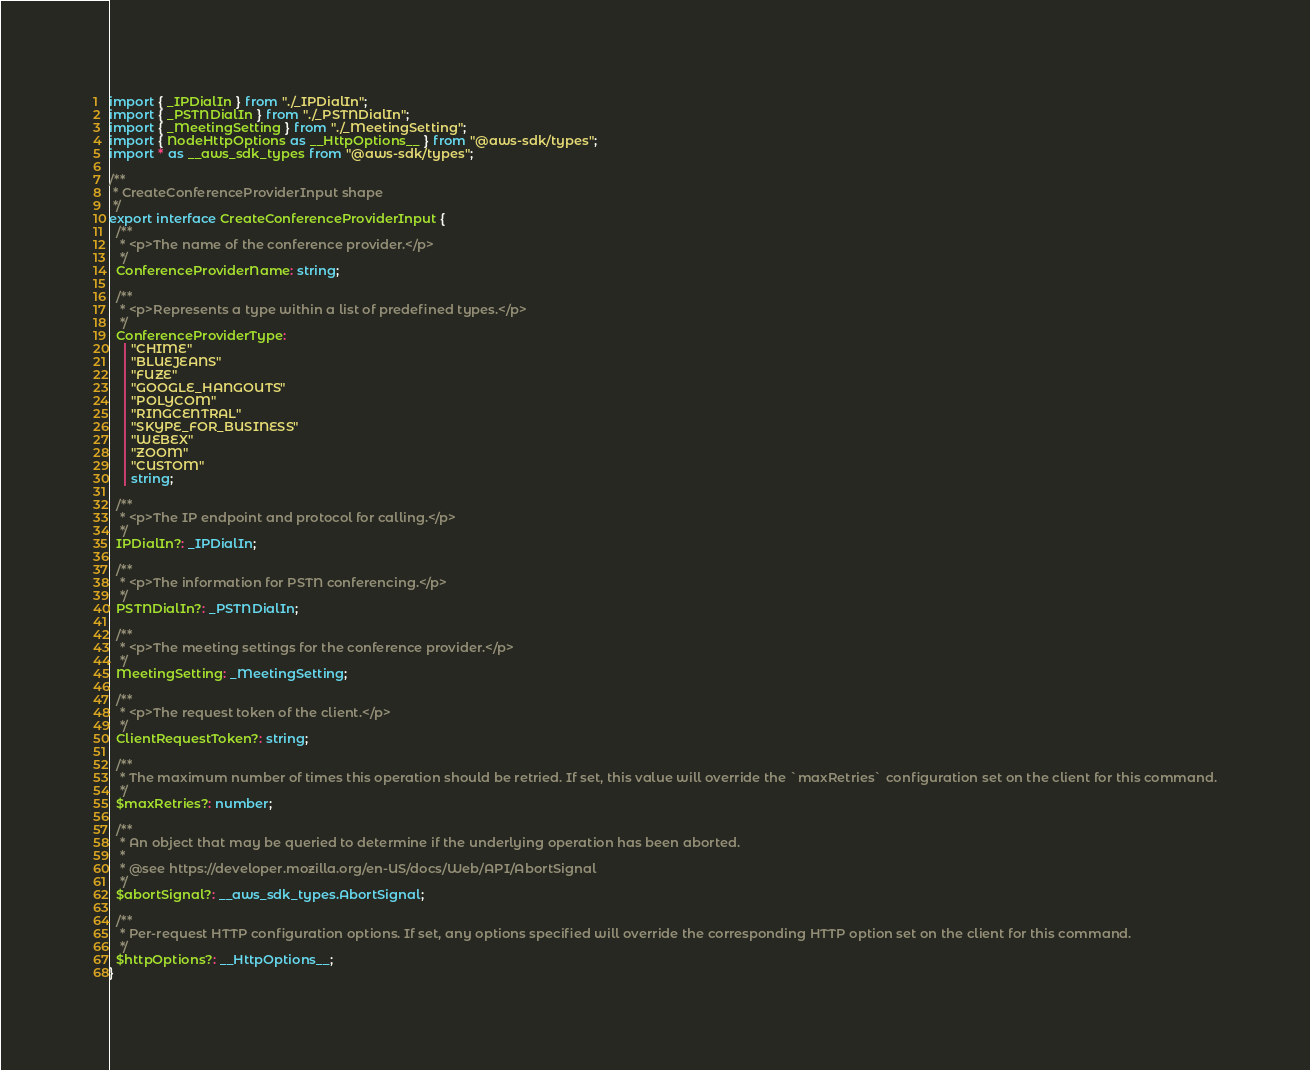Convert code to text. <code><loc_0><loc_0><loc_500><loc_500><_TypeScript_>import { _IPDialIn } from "./_IPDialIn";
import { _PSTNDialIn } from "./_PSTNDialIn";
import { _MeetingSetting } from "./_MeetingSetting";
import { NodeHttpOptions as __HttpOptions__ } from "@aws-sdk/types";
import * as __aws_sdk_types from "@aws-sdk/types";

/**
 * CreateConferenceProviderInput shape
 */
export interface CreateConferenceProviderInput {
  /**
   * <p>The name of the conference provider.</p>
   */
  ConferenceProviderName: string;

  /**
   * <p>Represents a type within a list of predefined types.</p>
   */
  ConferenceProviderType:
    | "CHIME"
    | "BLUEJEANS"
    | "FUZE"
    | "GOOGLE_HANGOUTS"
    | "POLYCOM"
    | "RINGCENTRAL"
    | "SKYPE_FOR_BUSINESS"
    | "WEBEX"
    | "ZOOM"
    | "CUSTOM"
    | string;

  /**
   * <p>The IP endpoint and protocol for calling.</p>
   */
  IPDialIn?: _IPDialIn;

  /**
   * <p>The information for PSTN conferencing.</p>
   */
  PSTNDialIn?: _PSTNDialIn;

  /**
   * <p>The meeting settings for the conference provider.</p>
   */
  MeetingSetting: _MeetingSetting;

  /**
   * <p>The request token of the client.</p>
   */
  ClientRequestToken?: string;

  /**
   * The maximum number of times this operation should be retried. If set, this value will override the `maxRetries` configuration set on the client for this command.
   */
  $maxRetries?: number;

  /**
   * An object that may be queried to determine if the underlying operation has been aborted.
   *
   * @see https://developer.mozilla.org/en-US/docs/Web/API/AbortSignal
   */
  $abortSignal?: __aws_sdk_types.AbortSignal;

  /**
   * Per-request HTTP configuration options. If set, any options specified will override the corresponding HTTP option set on the client for this command.
   */
  $httpOptions?: __HttpOptions__;
}
</code> 